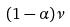<formula> <loc_0><loc_0><loc_500><loc_500>( 1 - \alpha ) \nu</formula> 